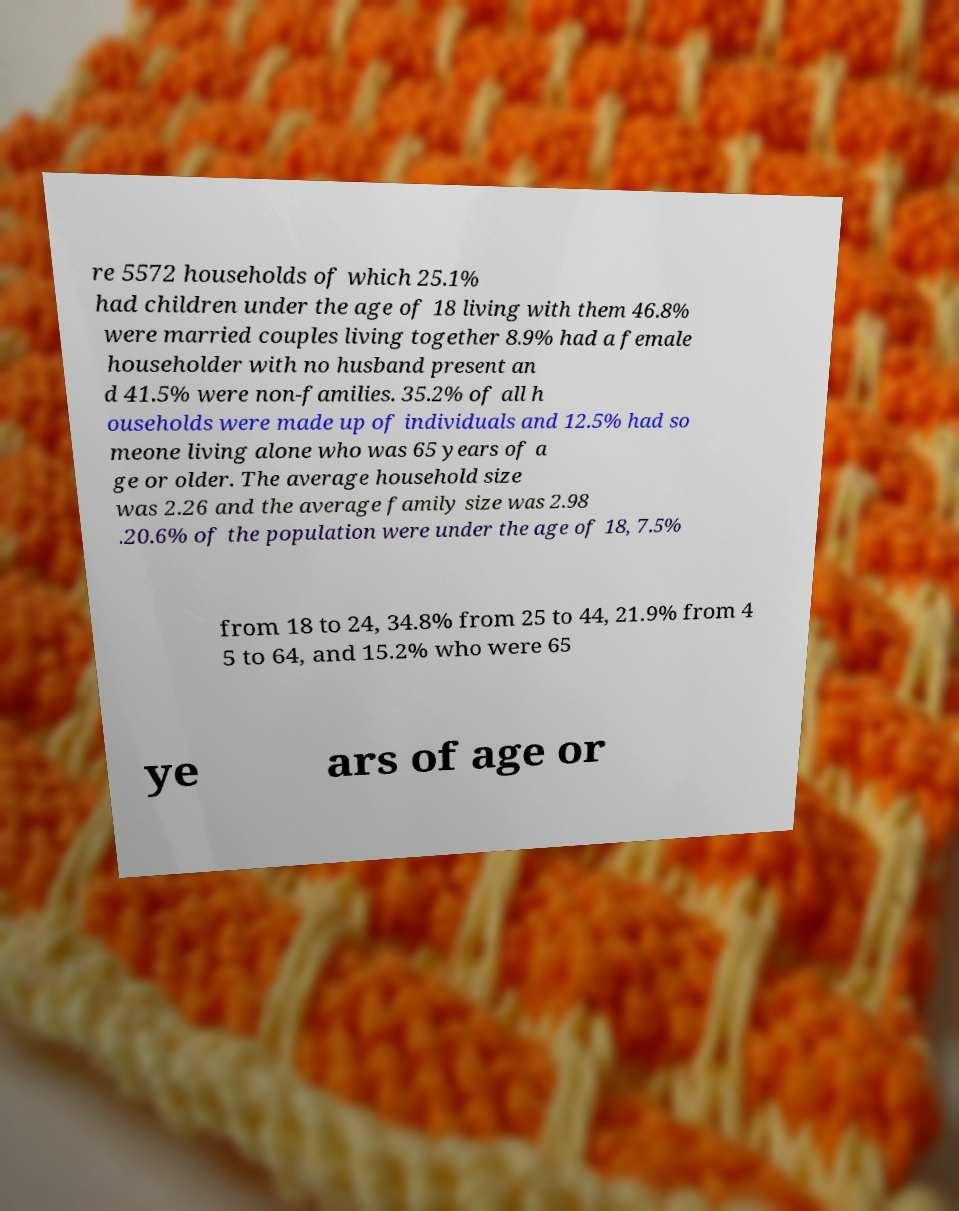Can you read and provide the text displayed in the image?This photo seems to have some interesting text. Can you extract and type it out for me? re 5572 households of which 25.1% had children under the age of 18 living with them 46.8% were married couples living together 8.9% had a female householder with no husband present an d 41.5% were non-families. 35.2% of all h ouseholds were made up of individuals and 12.5% had so meone living alone who was 65 years of a ge or older. The average household size was 2.26 and the average family size was 2.98 .20.6% of the population were under the age of 18, 7.5% from 18 to 24, 34.8% from 25 to 44, 21.9% from 4 5 to 64, and 15.2% who were 65 ye ars of age or 